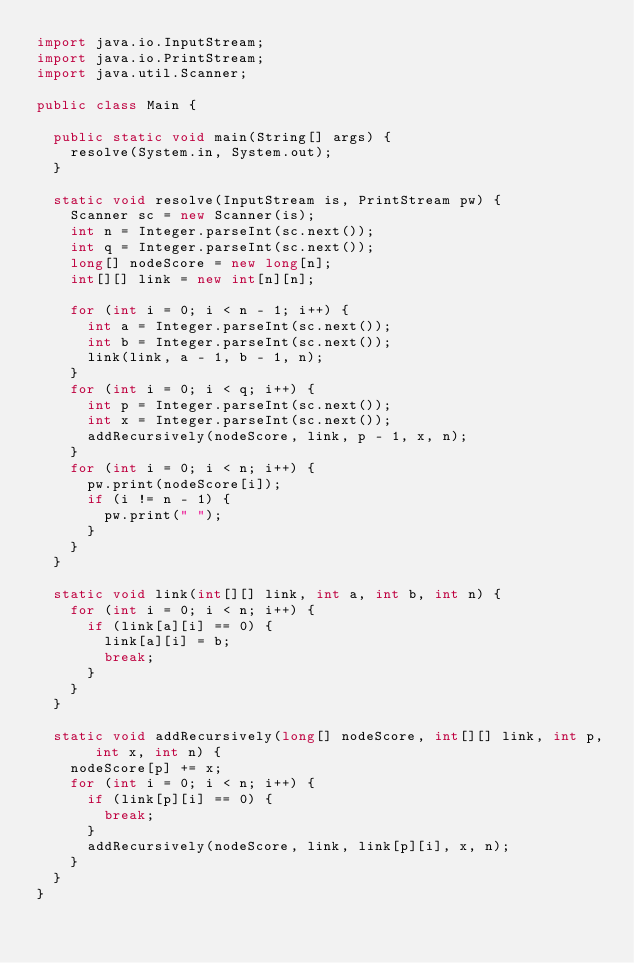Convert code to text. <code><loc_0><loc_0><loc_500><loc_500><_Java_>import java.io.InputStream;
import java.io.PrintStream;
import java.util.Scanner;

public class Main {

  public static void main(String[] args) {
    resolve(System.in, System.out);
  }

  static void resolve(InputStream is, PrintStream pw) {
    Scanner sc = new Scanner(is);
    int n = Integer.parseInt(sc.next());
    int q = Integer.parseInt(sc.next());
    long[] nodeScore = new long[n];
    int[][] link = new int[n][n];

    for (int i = 0; i < n - 1; i++) {
      int a = Integer.parseInt(sc.next());
      int b = Integer.parseInt(sc.next());
      link(link, a - 1, b - 1, n);
    }
    for (int i = 0; i < q; i++) {
      int p = Integer.parseInt(sc.next());
      int x = Integer.parseInt(sc.next());
      addRecursively(nodeScore, link, p - 1, x, n);
    }
    for (int i = 0; i < n; i++) {
      pw.print(nodeScore[i]);
      if (i != n - 1) {
        pw.print(" ");
      }
    }
  }

  static void link(int[][] link, int a, int b, int n) {
    for (int i = 0; i < n; i++) {
      if (link[a][i] == 0) {
        link[a][i] = b;
        break;
      }
    }
  }

  static void addRecursively(long[] nodeScore, int[][] link, int p, int x, int n) {
    nodeScore[p] += x;
    for (int i = 0; i < n; i++) {
      if (link[p][i] == 0) {
        break;
      }
      addRecursively(nodeScore, link, link[p][i], x, n);
    }
  }
}
</code> 